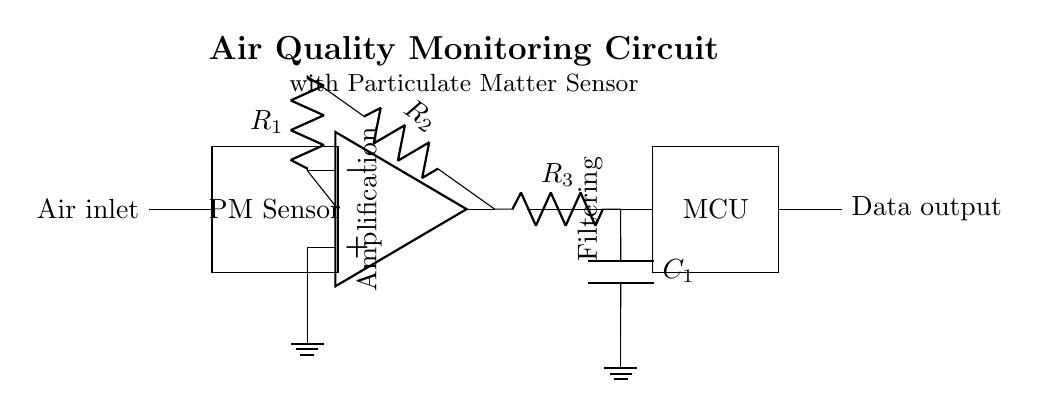What is the purpose of the PM sensor? The PM sensor is designed to measure particulate matter in the air. This information is essential for assessing air quality, especially in urban environments.
Answer: Measure particulate matter What does the MCU do in this circuit? The microcontroller (MCU) processes the data received from the PM sensor and likely manages the output signals, allowing for further analysis or display of air quality data.
Answer: Processes data How many resistors are present in the amplifier section? There are two resistors labeled R1 and R2 connected in the amplifier section of the circuit.
Answer: Two What type of filter is utilized in this circuit? The circuit employs a low-pass filter comprising a resistor and a capacitor, which is used to allow signals below a certain frequency to pass and attenuate those above it.
Answer: Low-pass filter What is the role of the low-pass filter in this circuit? The low-pass filter smooths out the amplified signal from the PM sensor by removing high-frequency noise, enabling cleaner data for the MCU to process.
Answer: Smooths signal What does the air inlet represent in the system? The air inlet indicates where air is drawn into the system for analysis by the particulate matter sensor, allowing the circuit to monitor environmental air quality accurately.
Answer: Air intake What is indicated by the label "Amplification" in the circuit? The "Amplification" label suggests that this section of the circuit increases the strength of the signal received from the PM sensor, which is necessary for accurate measurements.
Answer: Signal strengthening 